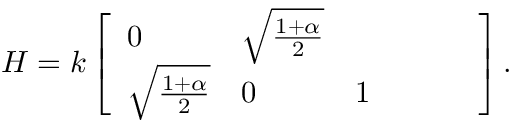<formula> <loc_0><loc_0><loc_500><loc_500>H = k \left [ \begin{array} { l l l l l l } { 0 } & { \sqrt { \frac { 1 + \alpha } { 2 } } } \\ { \sqrt { \frac { 1 + \alpha } { 2 } } } & { 0 } & { 1 } \end{array} \right ] .</formula> 